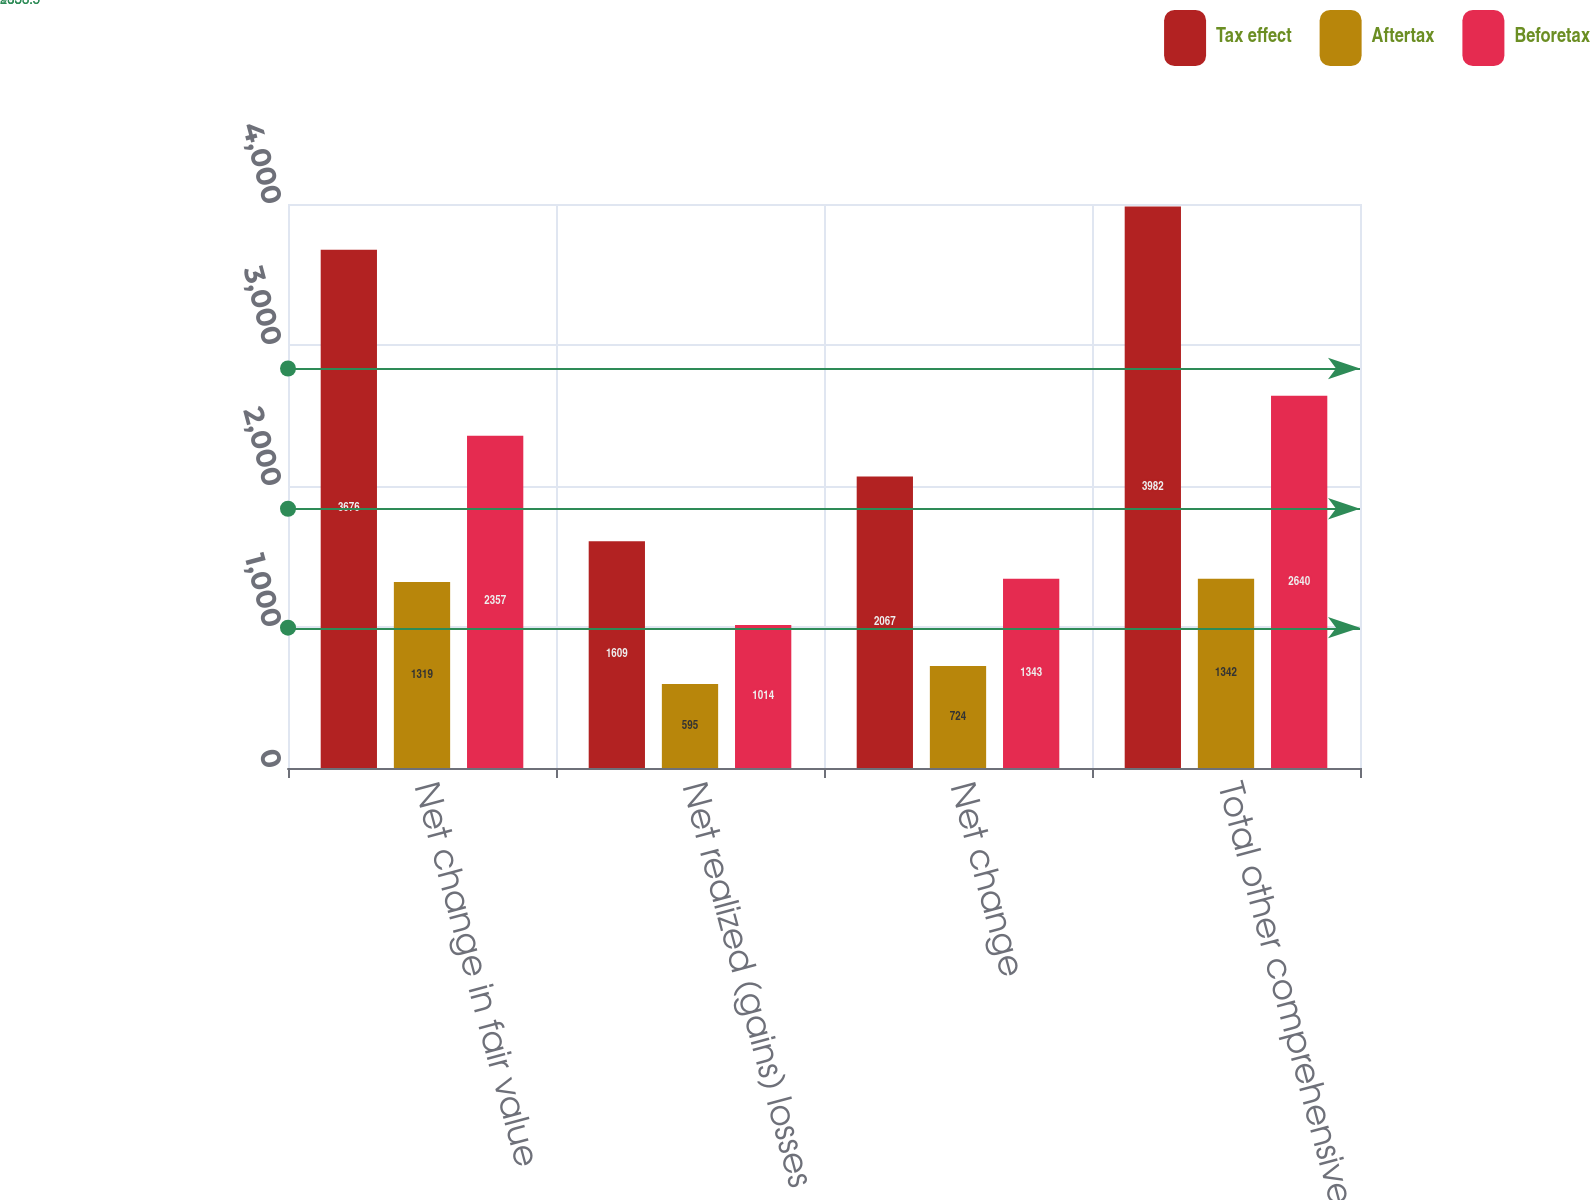<chart> <loc_0><loc_0><loc_500><loc_500><stacked_bar_chart><ecel><fcel>Net change in fair value<fcel>Net realized (gains) losses<fcel>Net change<fcel>Total other comprehensive<nl><fcel>Tax effect<fcel>3676<fcel>1609<fcel>2067<fcel>3982<nl><fcel>Aftertax<fcel>1319<fcel>595<fcel>724<fcel>1342<nl><fcel>Beforetax<fcel>2357<fcel>1014<fcel>1343<fcel>2640<nl></chart> 